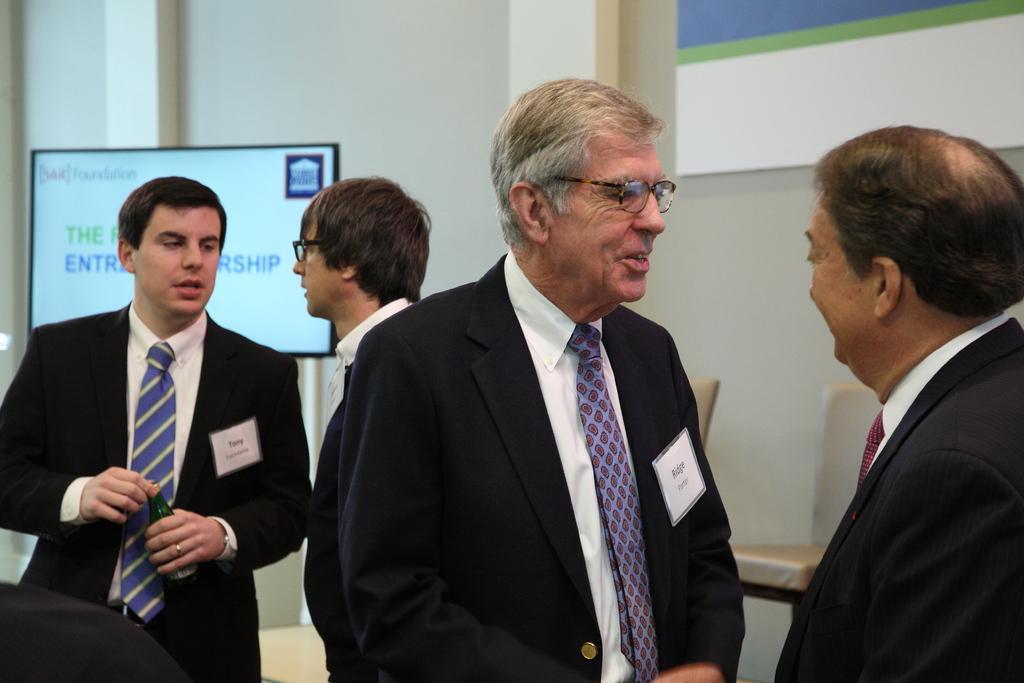How would you summarize this image in a sentence or two? In this image I can see 4 people standing in a room. They are wearing suit and talking to each other. There is a screen and chairs at the back. 